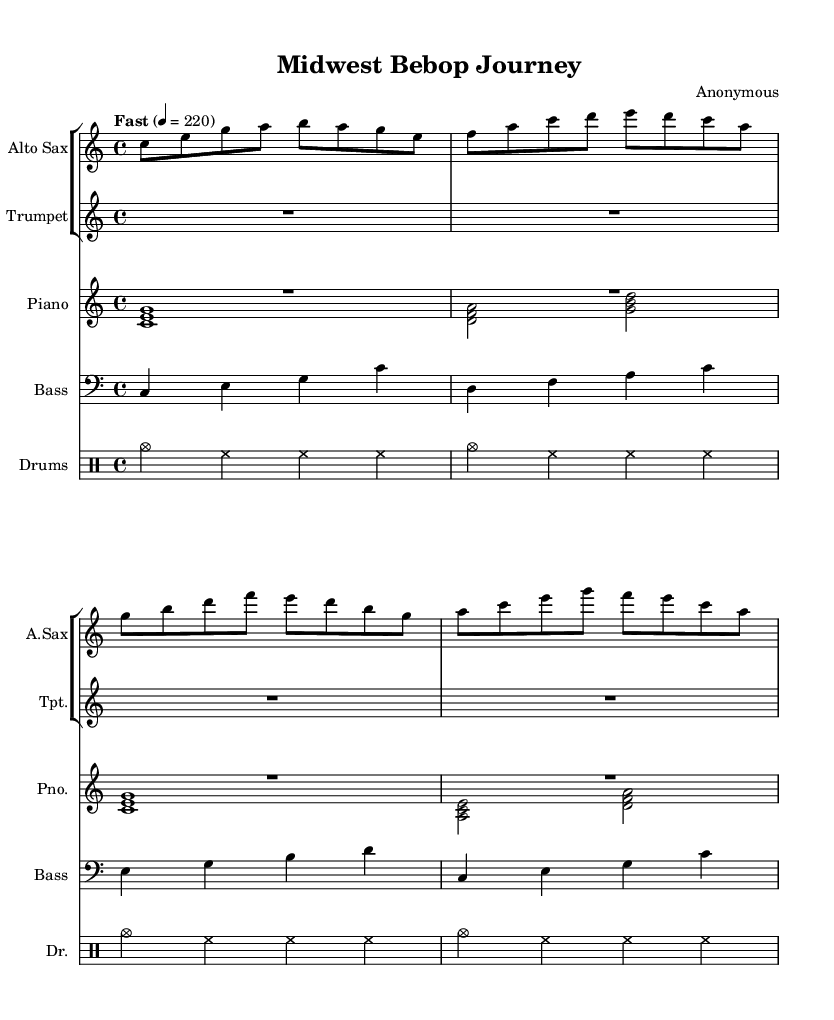What is the key signature of this music? The key signature is C major, which has no sharps or flats.
Answer: C major What is the time signature of this composition? The time signature is indicated by the '4/4' in the music, meaning there are four beats in each measure.
Answer: 4/4 What is the tempo marking given for this piece? The tempo marking is "Fast" with a metronome marking of quarter note = 220 beats per minute, indicating a quick tempo.
Answer: Fast, 220 How many measures are in the alto sax part shown? By counting the bars in the alto sax part, there are a total of four measures presented.
Answer: 4 Which instruments are indicated in the score? The score features an alto saxophone, trumpet, piano, bass, and drums, representing a typical jazz ensemble configuration.
Answer: Alto Sax, Trumpet, Piano, Bass, Drums Identify the rhythmic pattern predominantly used in the drums part. The drums part consistently uses cymbals and hi-hats on every beat, establishing a driving pulse typical of bebop jazz.
Answer: Cymbals and hi-hats What type of ensemble does this composition represent? This composition features a small combo setup, common in bebop jazz, which allows for interactive improvisation among musicians.
Answer: Combo 